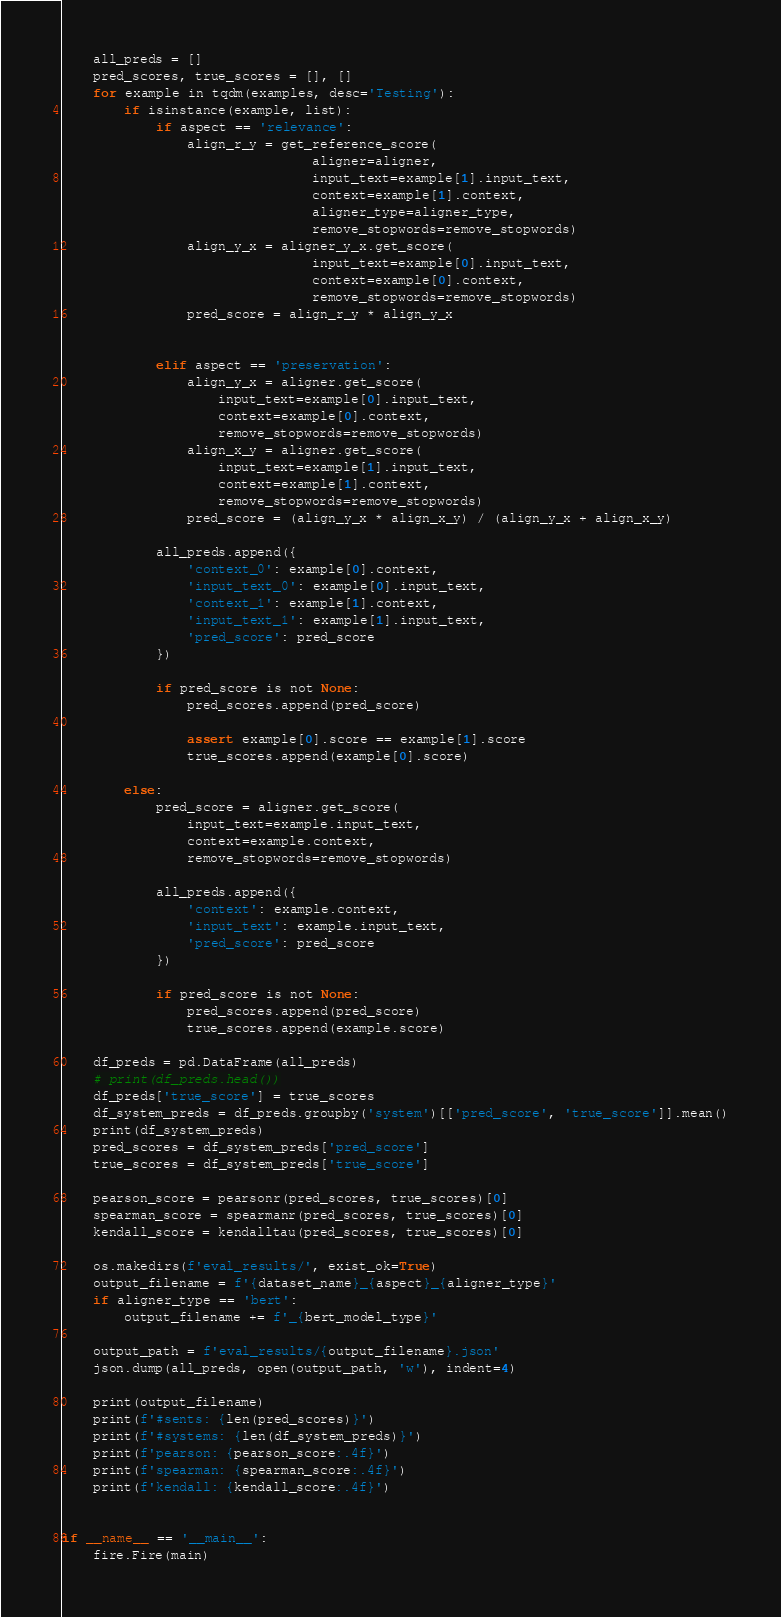<code> <loc_0><loc_0><loc_500><loc_500><_Python_>    all_preds = []
    pred_scores, true_scores = [], []
    for example in tqdm(examples, desc='Testing'):
        if isinstance(example, list):
            if aspect == 'relevance':
                align_r_y = get_reference_score(
                                aligner=aligner, 
                                input_text=example[1].input_text, 
                                context=example[1].context, 
                                aligner_type=aligner_type, 
                                remove_stopwords=remove_stopwords)
                align_y_x = aligner_y_x.get_score(
                                input_text=example[0].input_text,
                                context=example[0].context,
                                remove_stopwords=remove_stopwords)
                pred_score = align_r_y * align_y_x
                    

            elif aspect == 'preservation':
                align_y_x = aligner.get_score(
                    input_text=example[0].input_text,
                    context=example[0].context,
                    remove_stopwords=remove_stopwords)
                align_x_y = aligner.get_score(
                    input_text=example[1].input_text,
                    context=example[1].context,
                    remove_stopwords=remove_stopwords)
                pred_score = (align_y_x * align_x_y) / (align_y_x + align_x_y)

            all_preds.append({
                'context_0': example[0].context,
                'input_text_0': example[0].input_text,
                'context_1': example[1].context,
                'input_text_1': example[1].input_text,
                'pred_score': pred_score
            })

            if pred_score is not None:
                pred_scores.append(pred_score)

                assert example[0].score == example[1].score
                true_scores.append(example[0].score)

        else:
            pred_score = aligner.get_score(
                input_text=example.input_text,
                context=example.context,
                remove_stopwords=remove_stopwords)

            all_preds.append({
                'context': example.context,
                'input_text': example.input_text,
                'pred_score': pred_score
            })

            if pred_score is not None:
                pred_scores.append(pred_score)
                true_scores.append(example.score)
    
    df_preds = pd.DataFrame(all_preds)
    # print(df_preds.head())
    df_preds['true_score'] = true_scores
    df_system_preds = df_preds.groupby('system')[['pred_score', 'true_score']].mean()
    print(df_system_preds)
    pred_scores = df_system_preds['pred_score']
    true_scores = df_system_preds['true_score']
    
    pearson_score = pearsonr(pred_scores, true_scores)[0]
    spearman_score = spearmanr(pred_scores, true_scores)[0]
    kendall_score = kendalltau(pred_scores, true_scores)[0]

    os.makedirs(f'eval_results/', exist_ok=True)
    output_filename = f'{dataset_name}_{aspect}_{aligner_type}'
    if aligner_type == 'bert':
        output_filename += f'_{bert_model_type}'

    output_path = f'eval_results/{output_filename}.json'
    json.dump(all_preds, open(output_path, 'w'), indent=4)

    print(output_filename)
    print(f'#sents: {len(pred_scores)}')
    print(f'#systems: {len(df_system_preds)}')
    print(f'pearson: {pearson_score:.4f}')
    print(f'spearman: {spearman_score:.4f}')
    print(f'kendall: {kendall_score:.4f}')
    

if __name__ == '__main__':
    fire.Fire(main)</code> 